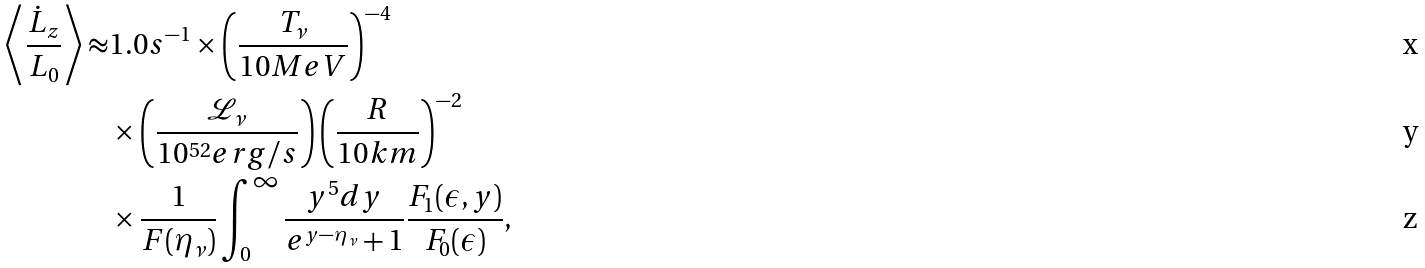Convert formula to latex. <formula><loc_0><loc_0><loc_500><loc_500>\left \langle \frac { \dot { L } _ { z } } { L _ { 0 } } \right \rangle \approx & 1 . 0 s ^ { - 1 } \times \left ( \frac { T _ { \nu } } { 1 0 M e V } \right ) ^ { - 4 } \\ & \times \left ( \frac { \mathcal { L } _ { \nu } } { 1 0 ^ { 5 2 } e r g / s } \right ) \left ( \frac { R } { 1 0 k m } \right ) ^ { - 2 } \\ & \times \frac { 1 } { F ( \eta _ { \nu } ) } \int _ { 0 } ^ { \infty } \frac { y ^ { 5 } d y } { e ^ { y - \eta _ { \nu } } + 1 } \frac { F _ { 1 } ( \epsilon , y ) } { F _ { 0 } ( \epsilon ) } ,</formula> 